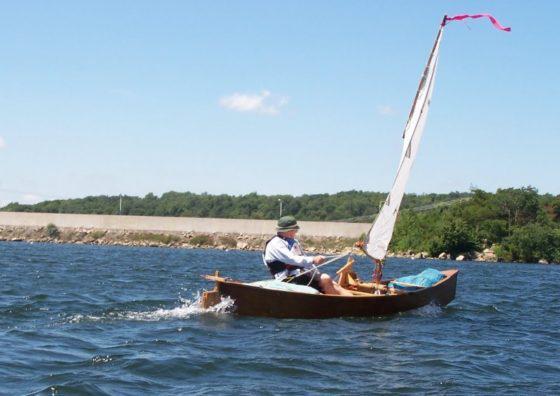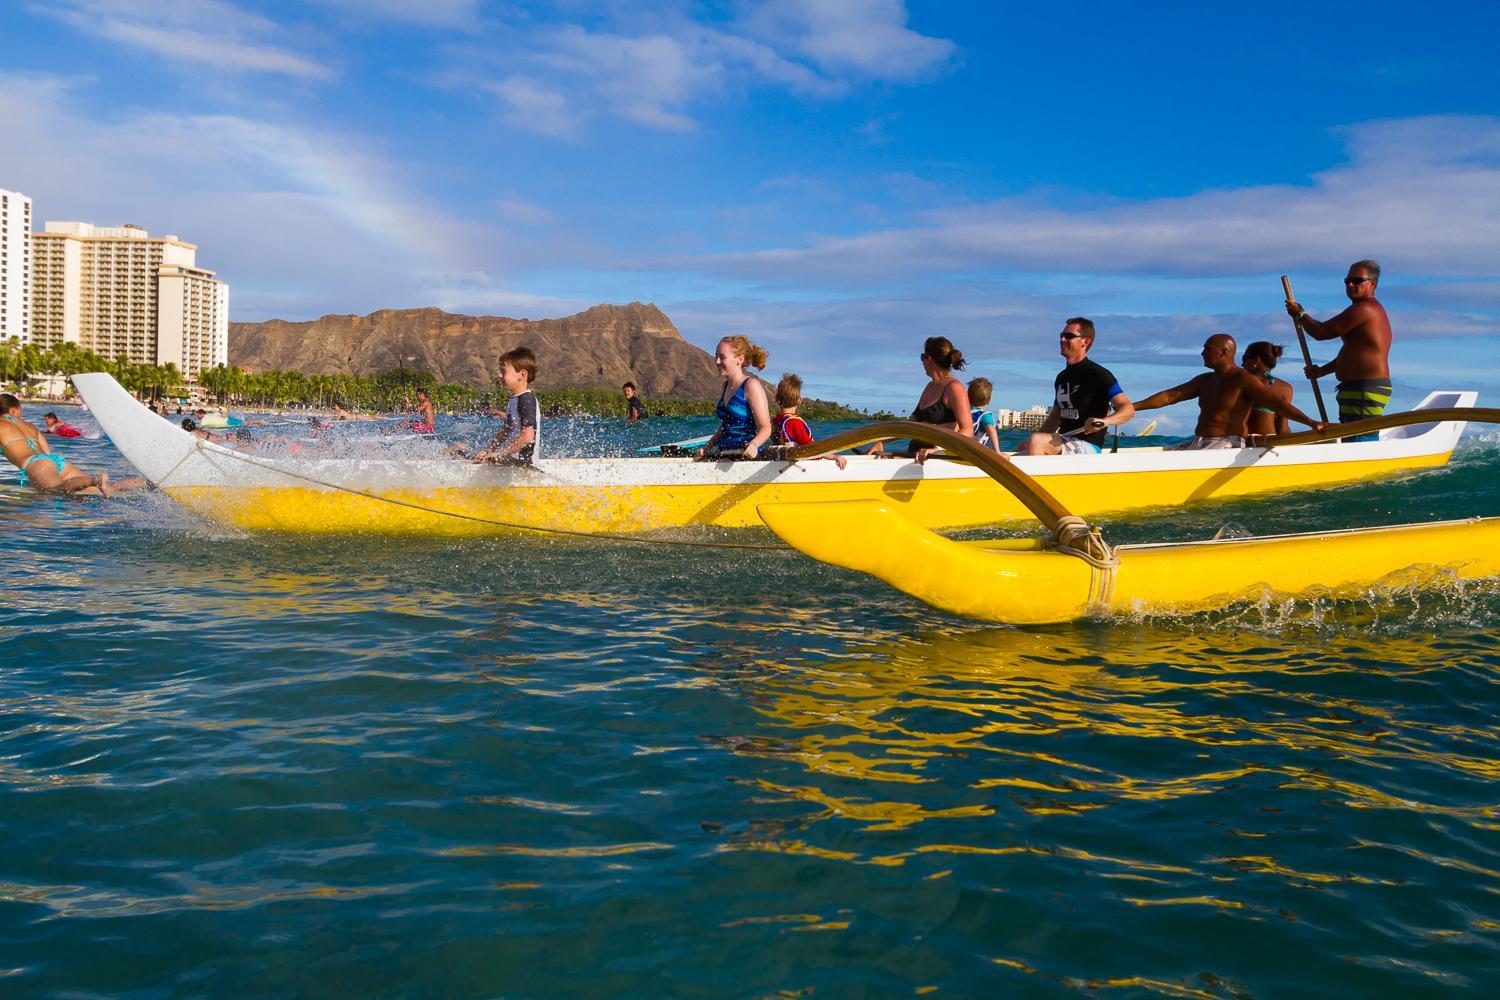The first image is the image on the left, the second image is the image on the right. For the images displayed, is the sentence "There are two vessels in the water in one of the images." factually correct? Answer yes or no. Yes. The first image is the image on the left, the second image is the image on the right. For the images displayed, is the sentence "An image shows one boat with at least four aboard going to the right." factually correct? Answer yes or no. No. 